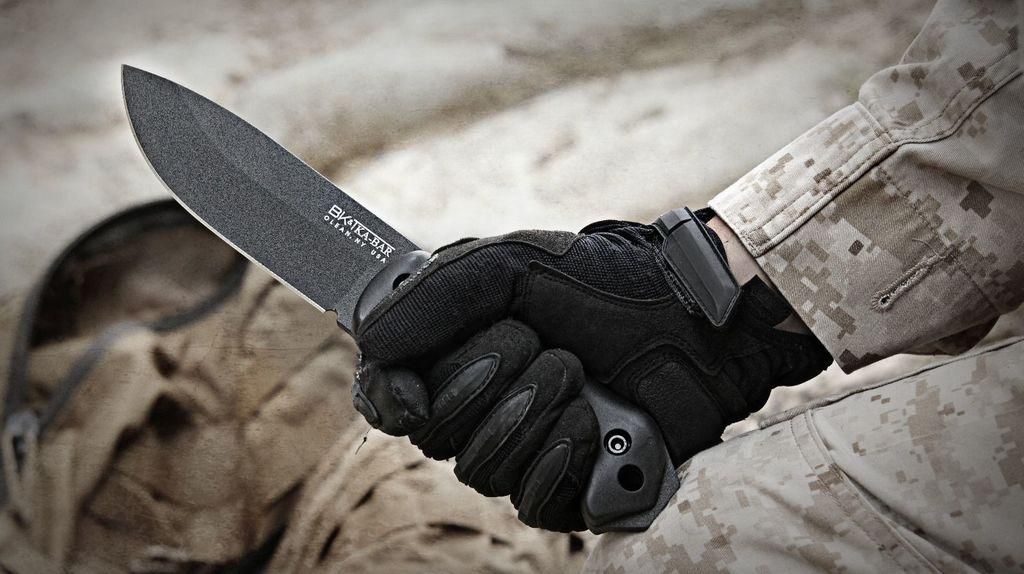What object can be seen in the image? There is a knife in the image. What is the color of the knife? The knife is black in color. Who or what is holding the knife? There is a human hand holding the knife. What is the hand wearing? The hand is wearing a black color glove. How would you describe the background of the image? The background of the image is blurred. What is the profit made from the rain in the image? There is no mention of profit or rain in the image; it only features a knife, a hand, and a glove. 